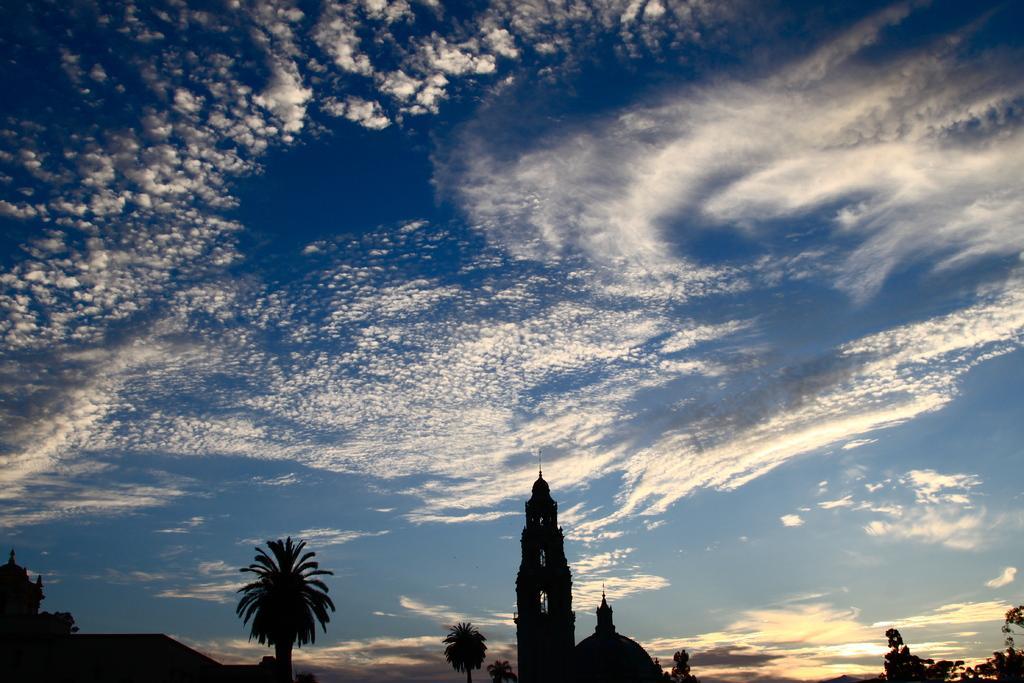Describe this image in one or two sentences. In this picture we can see trees, buildings and in the background we can see the sky with clouds. 